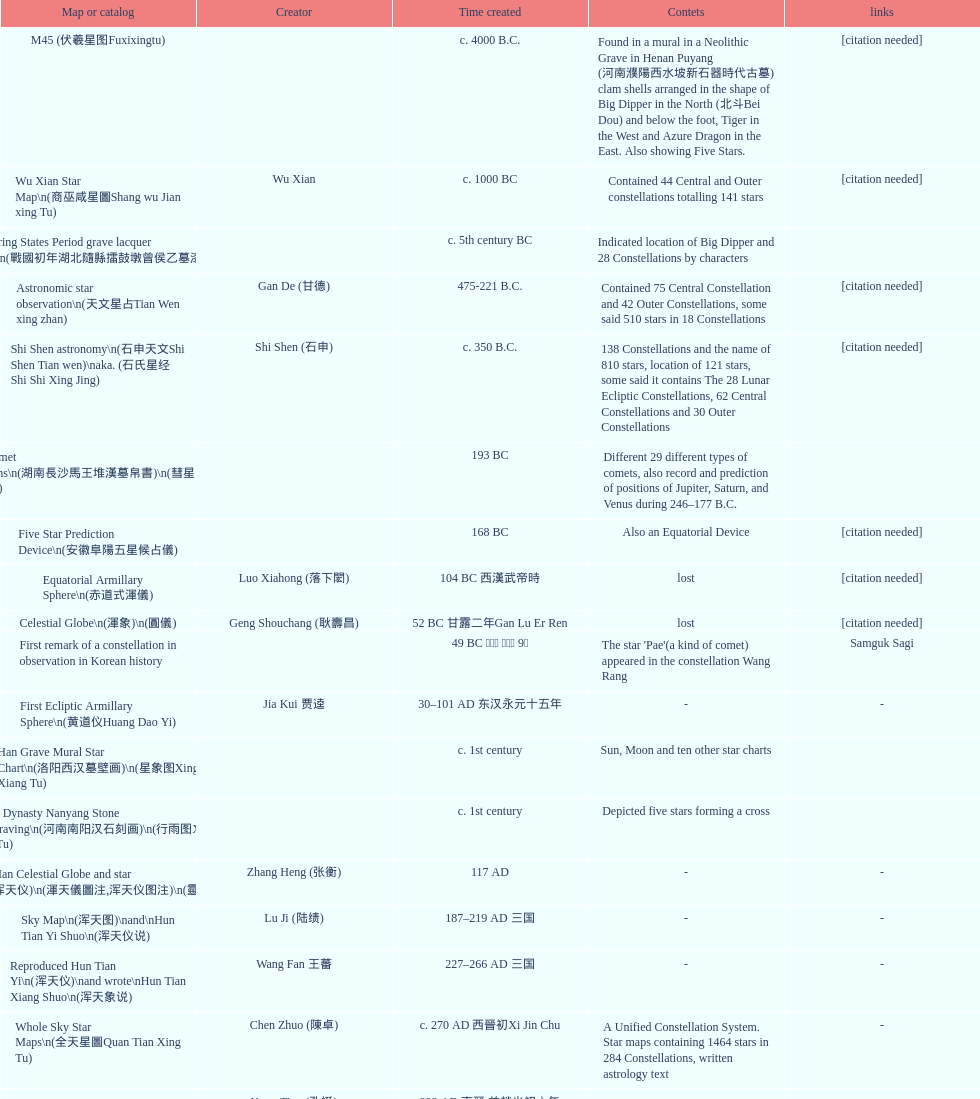Which was the first chinese star map known to have been created? M45 (伏羲星图Fuxixingtu). 